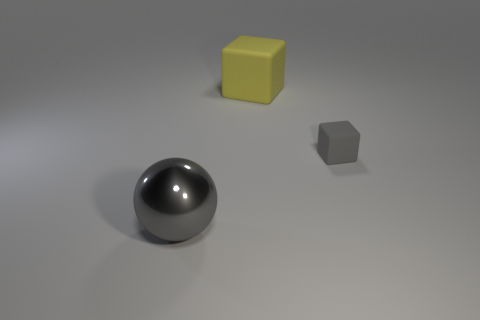How many other objects are there of the same size as the shiny sphere?
Give a very brief answer. 1. How many cylinders are either small gray rubber things or large metal objects?
Keep it short and to the point. 0. How many big objects are behind the big gray thing and in front of the gray rubber thing?
Your response must be concise. 0. Is the number of matte cubes in front of the big yellow matte cube the same as the number of gray metal balls that are to the right of the small rubber block?
Provide a short and direct response. No. Is the shape of the rubber object to the right of the yellow object the same as  the yellow object?
Your answer should be very brief. Yes. The thing that is behind the matte thing in front of the thing behind the small object is what shape?
Give a very brief answer. Cube. What is the shape of the metallic thing that is the same color as the small matte cube?
Provide a short and direct response. Sphere. There is a thing that is on the left side of the small gray rubber object and behind the large metal sphere; what is its material?
Offer a very short reply. Rubber. Are there fewer brown rubber spheres than spheres?
Provide a succinct answer. Yes. Does the small gray thing have the same shape as the large object in front of the small gray block?
Make the answer very short. No. 